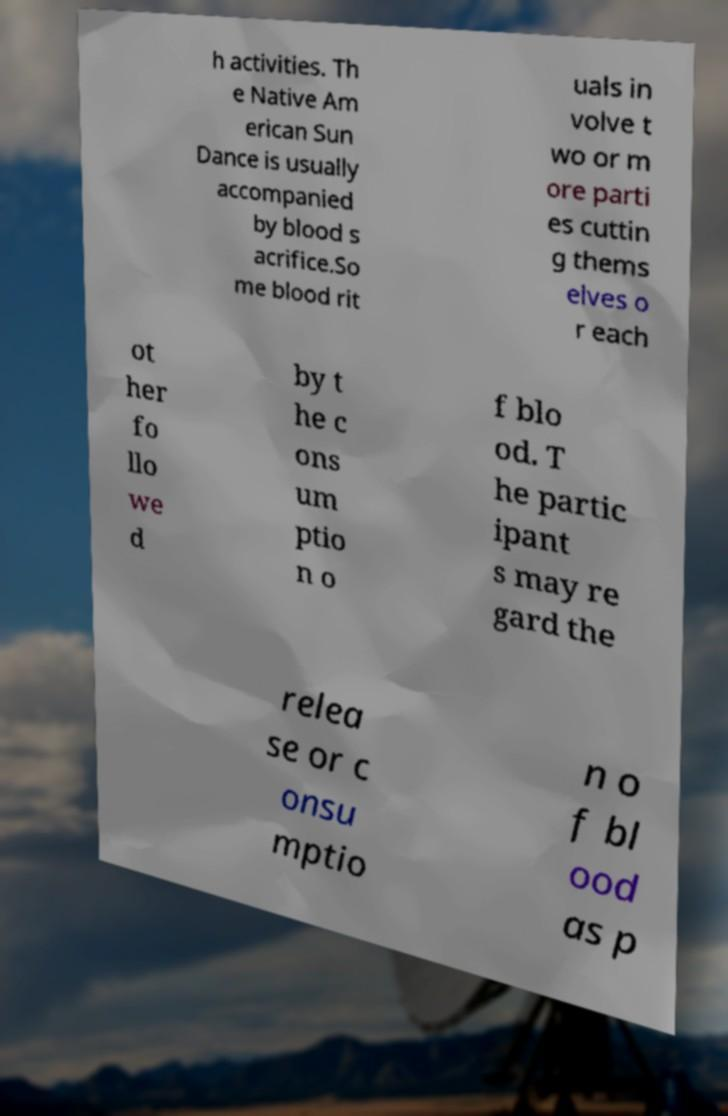For documentation purposes, I need the text within this image transcribed. Could you provide that? h activities. Th e Native Am erican Sun Dance is usually accompanied by blood s acrifice.So me blood rit uals in volve t wo or m ore parti es cuttin g thems elves o r each ot her fo llo we d by t he c ons um ptio n o f blo od. T he partic ipant s may re gard the relea se or c onsu mptio n o f bl ood as p 